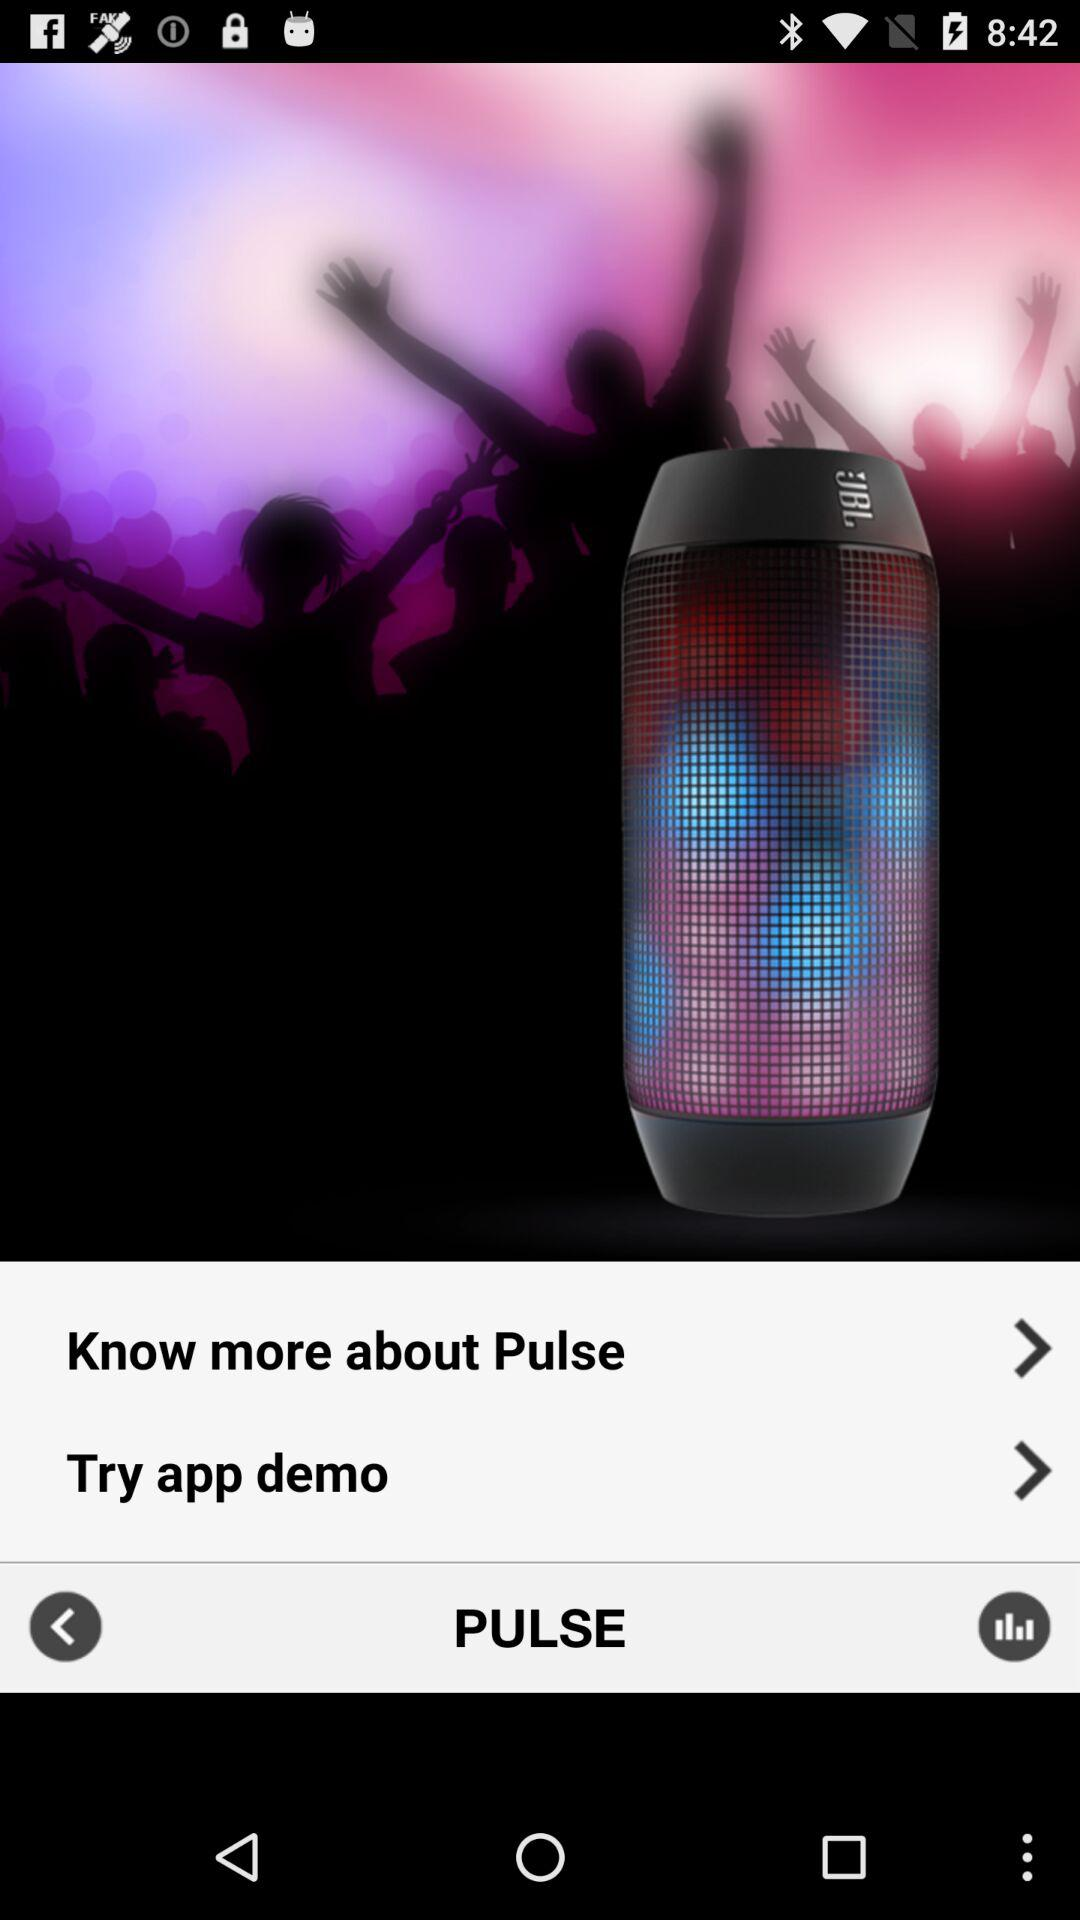Who is the developer of "Pulse"?
When the provided information is insufficient, respond with <no answer>. <no answer> 